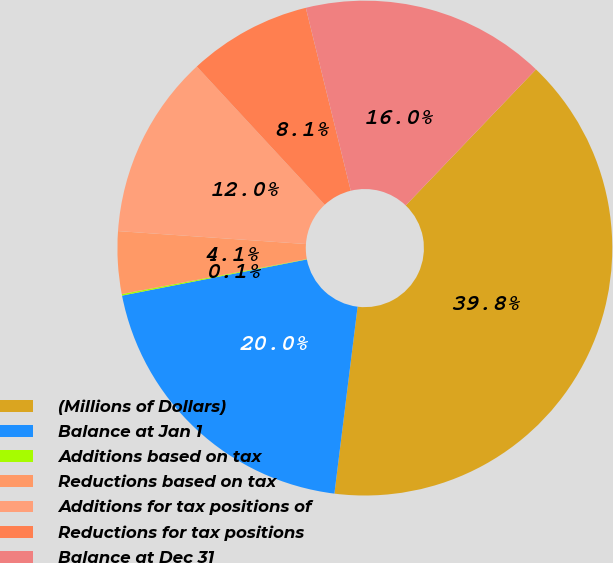Convert chart to OTSL. <chart><loc_0><loc_0><loc_500><loc_500><pie_chart><fcel>(Millions of Dollars)<fcel>Balance at Jan 1<fcel>Additions based on tax<fcel>Reductions based on tax<fcel>Additions for tax positions of<fcel>Reductions for tax positions<fcel>Balance at Dec 31<nl><fcel>39.81%<fcel>19.96%<fcel>0.1%<fcel>4.07%<fcel>12.02%<fcel>8.05%<fcel>15.99%<nl></chart> 